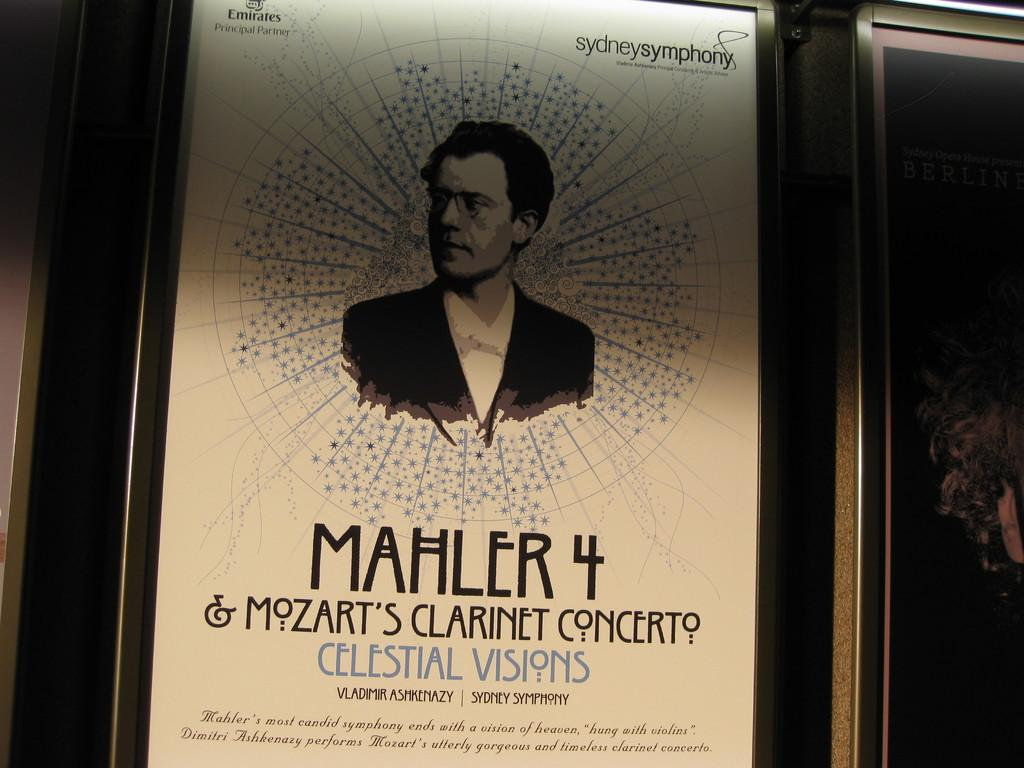<image>
Create a compact narrative representing the image presented. A clarinet concert by Mahler of celestial visions. 